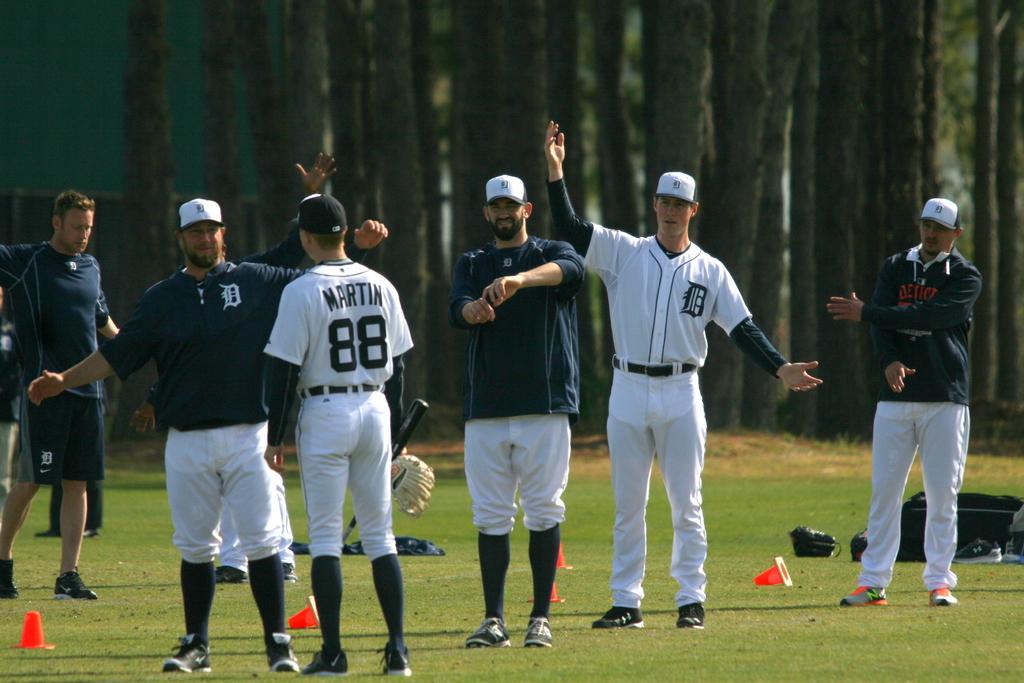What is the last name of the man wearing number 88?
Keep it short and to the point. Martin. 